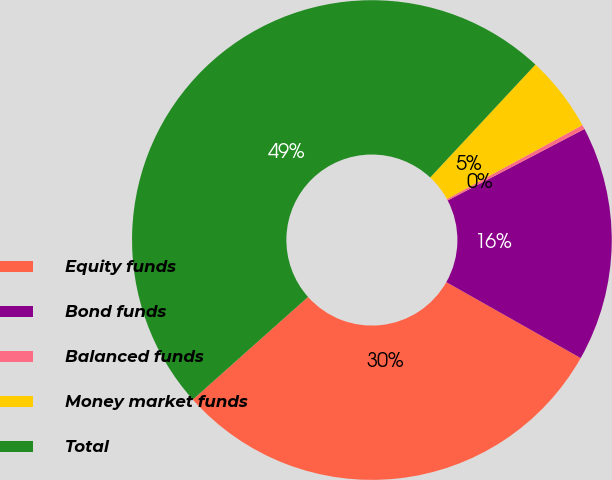Convert chart to OTSL. <chart><loc_0><loc_0><loc_500><loc_500><pie_chart><fcel>Equity funds<fcel>Bond funds<fcel>Balanced funds<fcel>Money market funds<fcel>Total<nl><fcel>30.23%<fcel>15.85%<fcel>0.29%<fcel>5.11%<fcel>48.52%<nl></chart> 